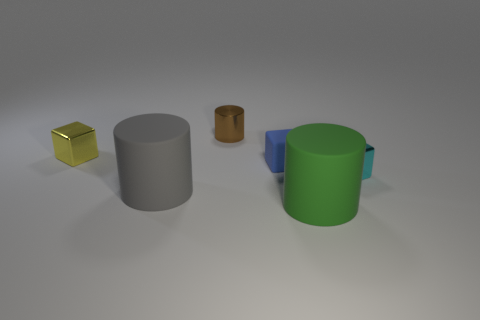Add 2 small cylinders. How many objects exist? 8 Subtract 1 gray cylinders. How many objects are left? 5 Subtract all green cylinders. Subtract all blue matte cubes. How many objects are left? 4 Add 3 big gray objects. How many big gray objects are left? 4 Add 6 small brown shiny things. How many small brown shiny things exist? 7 